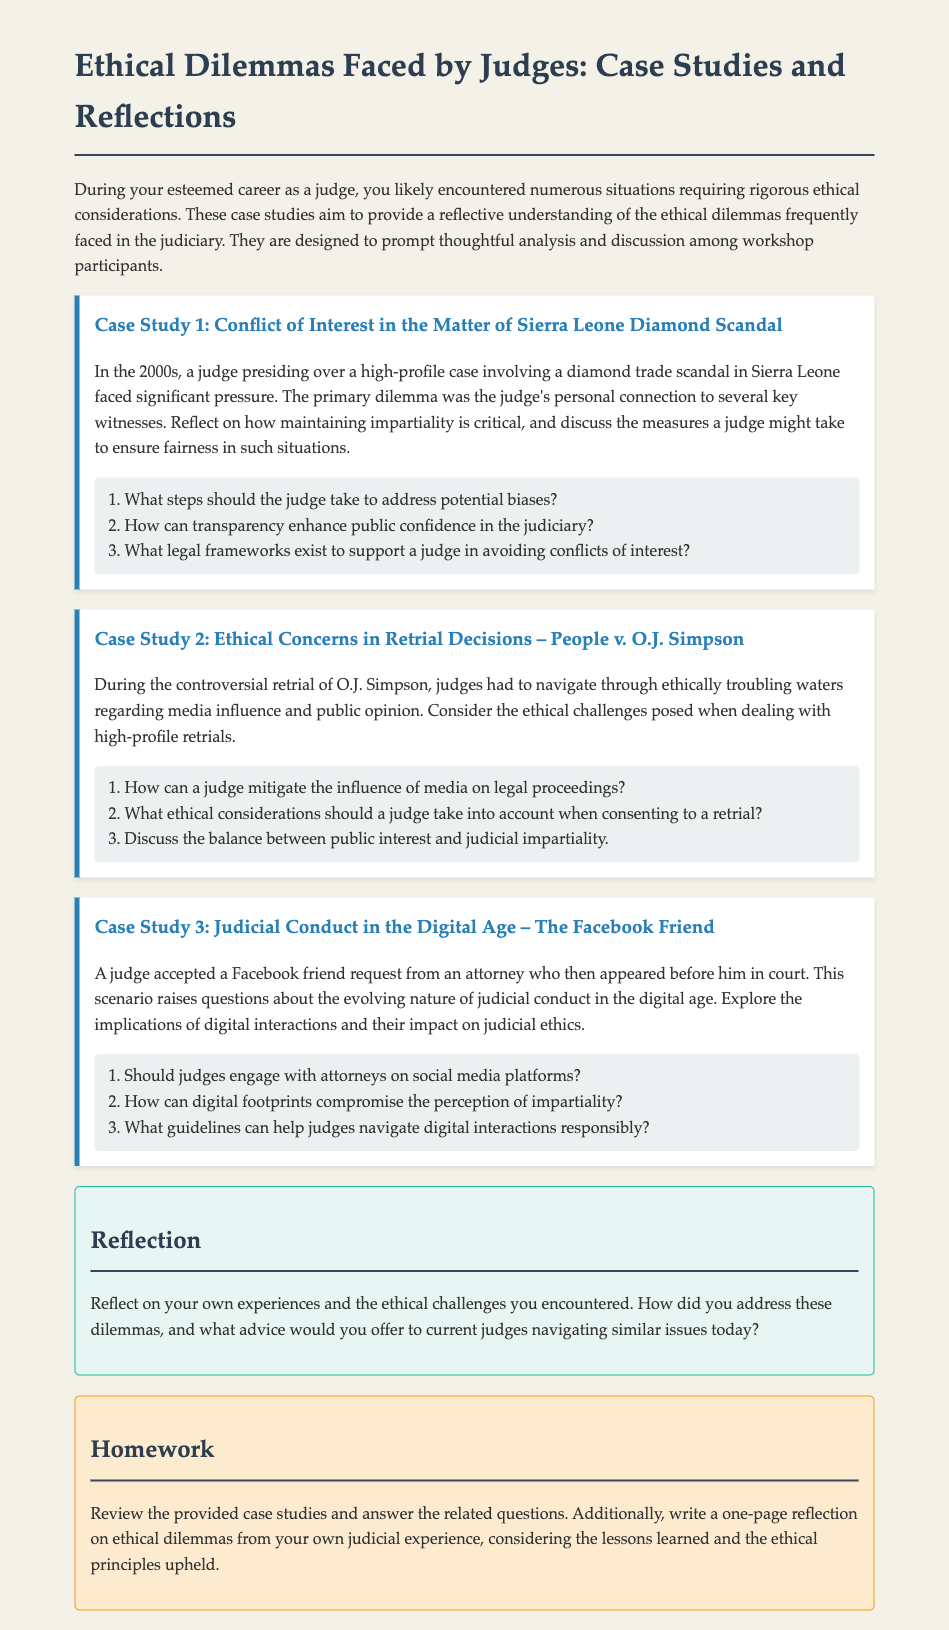What is the title of the document? The title of the document is presented at the top of the rendered document, summarizing its content, which is about ethical dilemmas faced by judges.
Answer: Ethical Dilemmas Faced by Judges: Case Studies and Reflections How many case studies are included in the document? The total number of case studies is indicated by the sections titled "Case Study 1," "Case Study 2," and "Case Study 3."
Answer: 3 What is the first case study about? The first case study is specifically mentioned in the title and introductory text, focusing on a significant ethical challenge related to a diamond scandal.
Answer: Conflict of Interest in the Matter of Sierra Leone Diamond Scandal What should judges consider regarding social media? The questions in the third case study prompt judges to think critically about their interactions with attorneys through social media and their implications.
Answer: Judicial conduct in the digital age What is a key component judges must maintain in legal proceedings? The questions prompt a discussion about an essential ethical principle necessary in judicial processes, especially under conflict situations.
Answer: Impartiality How should judges respond to media influence according to the document? The questions in the second case study suggest actions judges can take against external pressures affecting judicial decisions during high-profile cases.
Answer: Mitigation strategies What is the purpose of the reflection section? The reflection section encourages judges to think deeply about their personal experiences and share insights regarding ethical challenges faced in their judiciary career.
Answer: Reflection on experiences What type of interaction is questioned in Case Study 3? The third case study raises concerns about a specific kind of digital interaction between judges and legal representatives, reflecting ethical considerations.
Answer: Facebook Friend What is required in the homework assignment? The homework section outlines what the participants are expected to review and reflect on, leading to their written assignment.
Answer: Review case studies and answer questions 